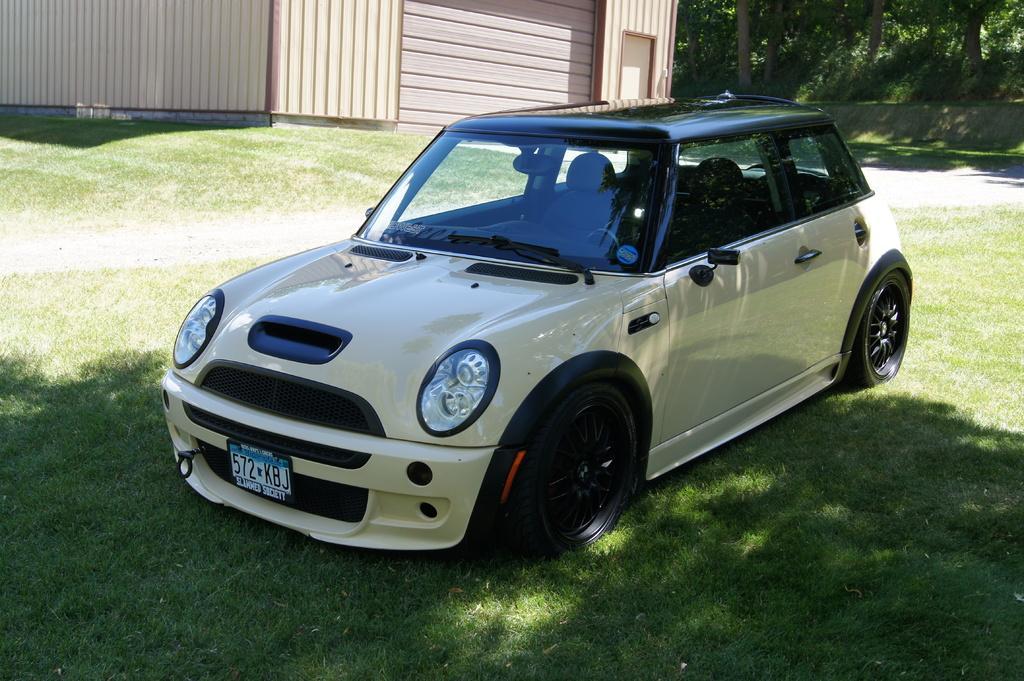Please provide a concise description of this image. In the picture there is a car parked on the grass under a tree shade and around the grass there are few trees and on the left side there is a wooden house. The climate is very sunny. 